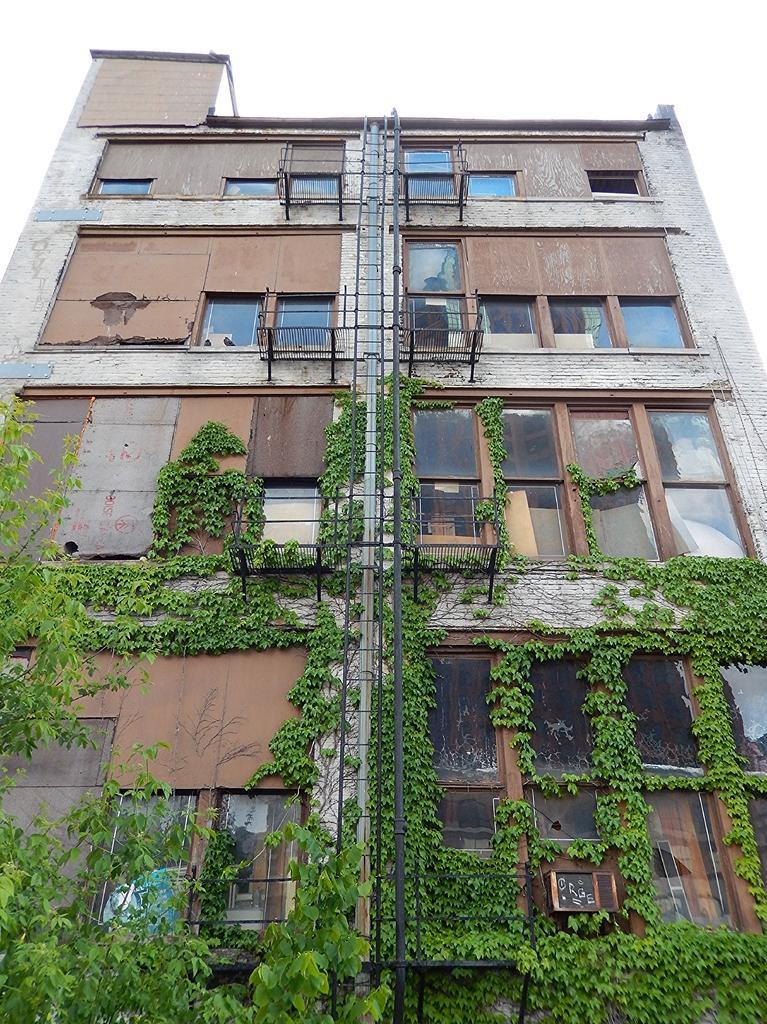How would you summarize this image in a sentence or two? In this image in the center there is a building and on the wall of the building there are plants. 